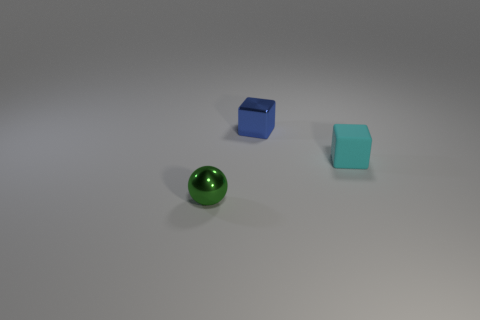What is the material of the small object that is on the left side of the small cyan cube and in front of the blue object?
Provide a succinct answer. Metal. Is the material of the tiny cyan block the same as the small sphere?
Ensure brevity in your answer.  No. What number of tiny red metallic cylinders are there?
Give a very brief answer. 0. There is a cube behind the tiny object on the right side of the block left of the cyan rubber object; what color is it?
Provide a short and direct response. Blue. How many small objects are both in front of the small blue block and behind the small green sphere?
Your answer should be compact. 1. What number of shiny objects are either big purple cubes or small green things?
Your response must be concise. 1. The tiny cube that is to the right of the metallic thing behind the small metal ball is made of what material?
Provide a short and direct response. Rubber. What is the shape of the green object that is the same size as the blue block?
Ensure brevity in your answer.  Sphere. Are there fewer small green metallic objects than tiny blue rubber cylinders?
Ensure brevity in your answer.  No. There is a metal thing that is behind the small cyan block; is there a small blue shiny block that is in front of it?
Give a very brief answer. No. 